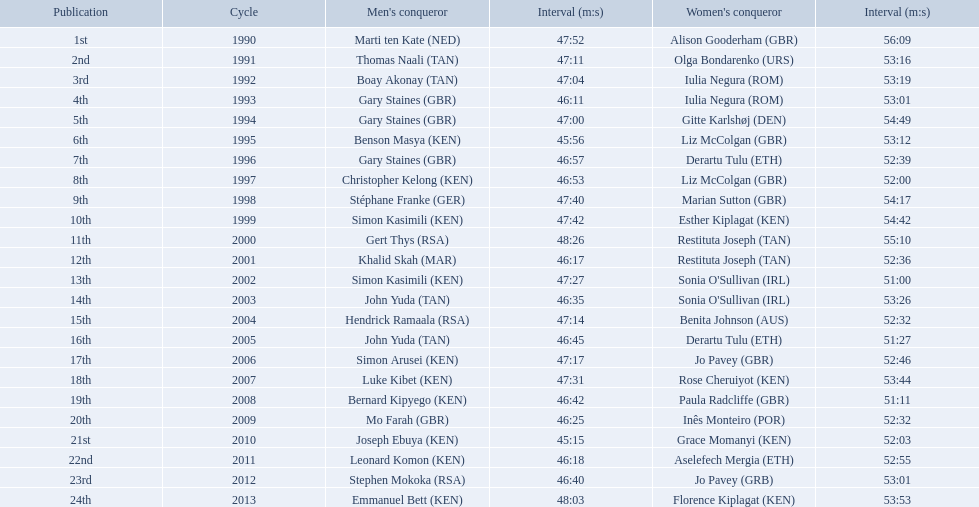What years were the races held? 1990, 1991, 1992, 1993, 1994, 1995, 1996, 1997, 1998, 1999, 2000, 2001, 2002, 2003, 2004, 2005, 2006, 2007, 2008, 2009, 2010, 2011, 2012, 2013. Who was the woman's winner of the 2003 race? Sonia O'Sullivan (IRL). What was her time? 53:26. Which runners are from kenya? (ken) Benson Masya (KEN), Christopher Kelong (KEN), Simon Kasimili (KEN), Simon Kasimili (KEN), Simon Arusei (KEN), Luke Kibet (KEN), Bernard Kipyego (KEN), Joseph Ebuya (KEN), Leonard Komon (KEN), Emmanuel Bett (KEN). Of these, which times are under 46 minutes? Benson Masya (KEN), Joseph Ebuya (KEN). Which of these runners had the faster time? Joseph Ebuya (KEN). 